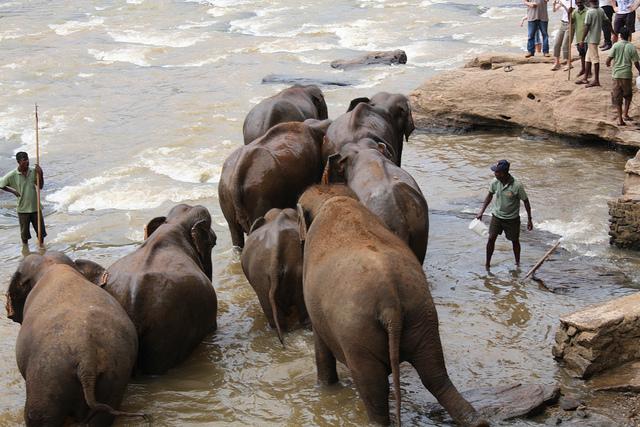Is this water very deep?
Be succinct. No. Was this picture taken in Europe?
Give a very brief answer. No. Are the animals been washed?
Answer briefly. Yes. 